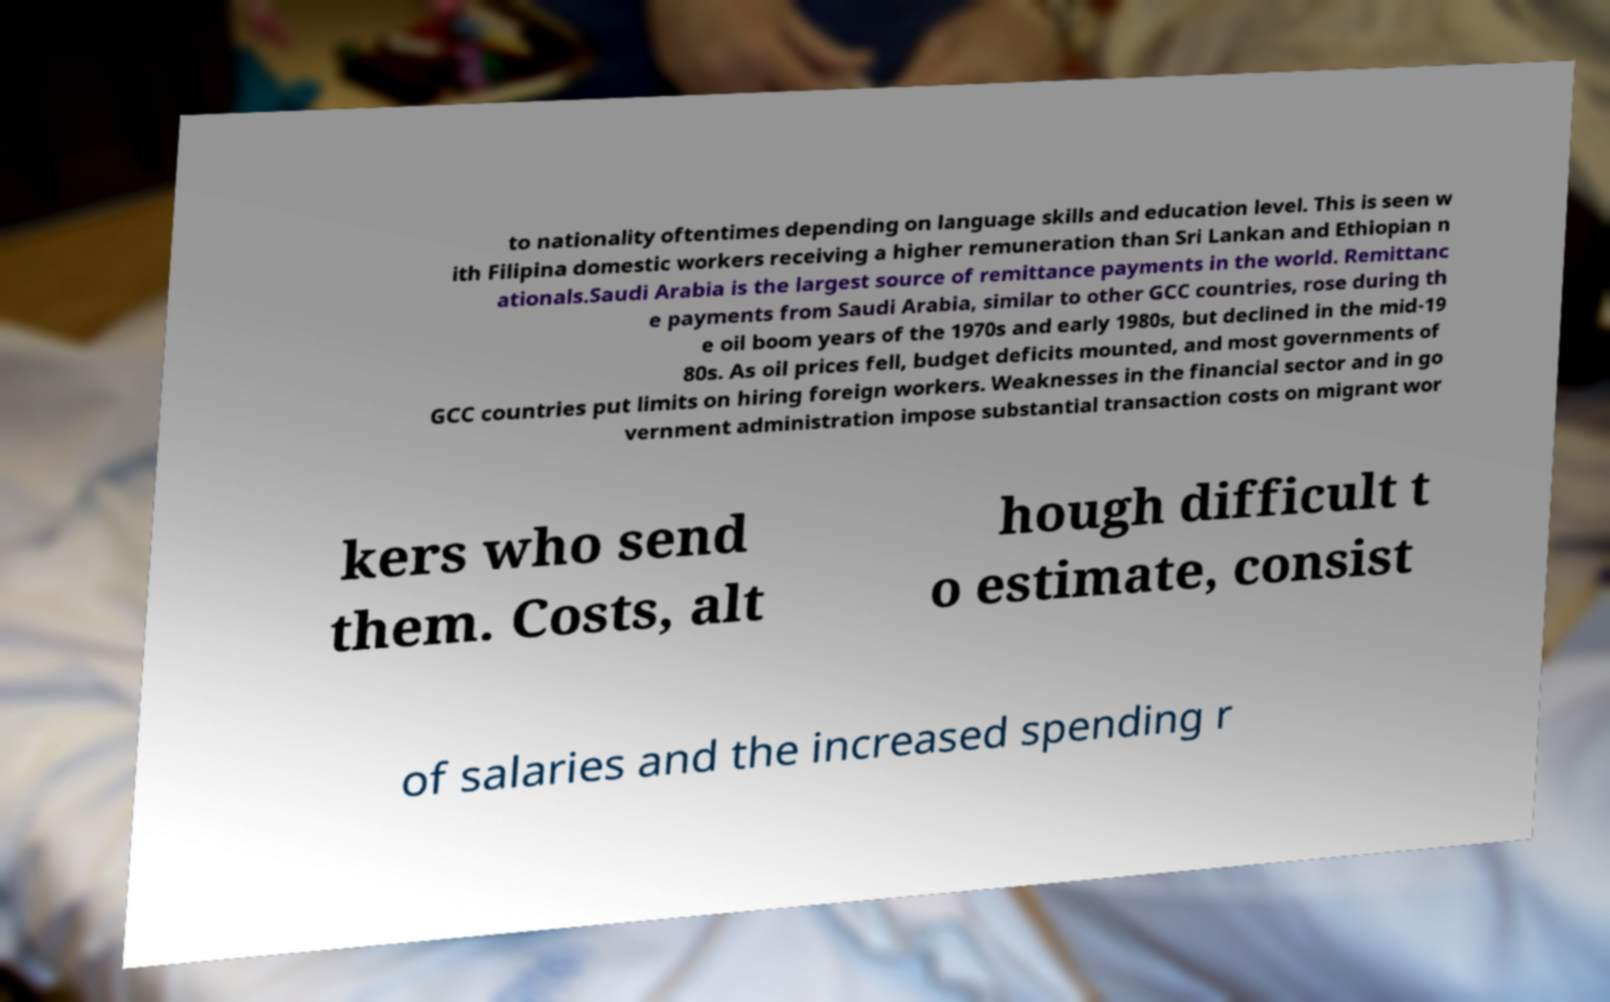I need the written content from this picture converted into text. Can you do that? to nationality oftentimes depending on language skills and education level. This is seen w ith Filipina domestic workers receiving a higher remuneration than Sri Lankan and Ethiopian n ationals.Saudi Arabia is the largest source of remittance payments in the world. Remittanc e payments from Saudi Arabia, similar to other GCC countries, rose during th e oil boom years of the 1970s and early 1980s, but declined in the mid-19 80s. As oil prices fell, budget deficits mounted, and most governments of GCC countries put limits on hiring foreign workers. Weaknesses in the financial sector and in go vernment administration impose substantial transaction costs on migrant wor kers who send them. Costs, alt hough difficult t o estimate, consist of salaries and the increased spending r 